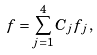<formula> <loc_0><loc_0><loc_500><loc_500>f = \sum _ { j = 1 } ^ { 4 } C _ { j } f _ { j } \, ,</formula> 